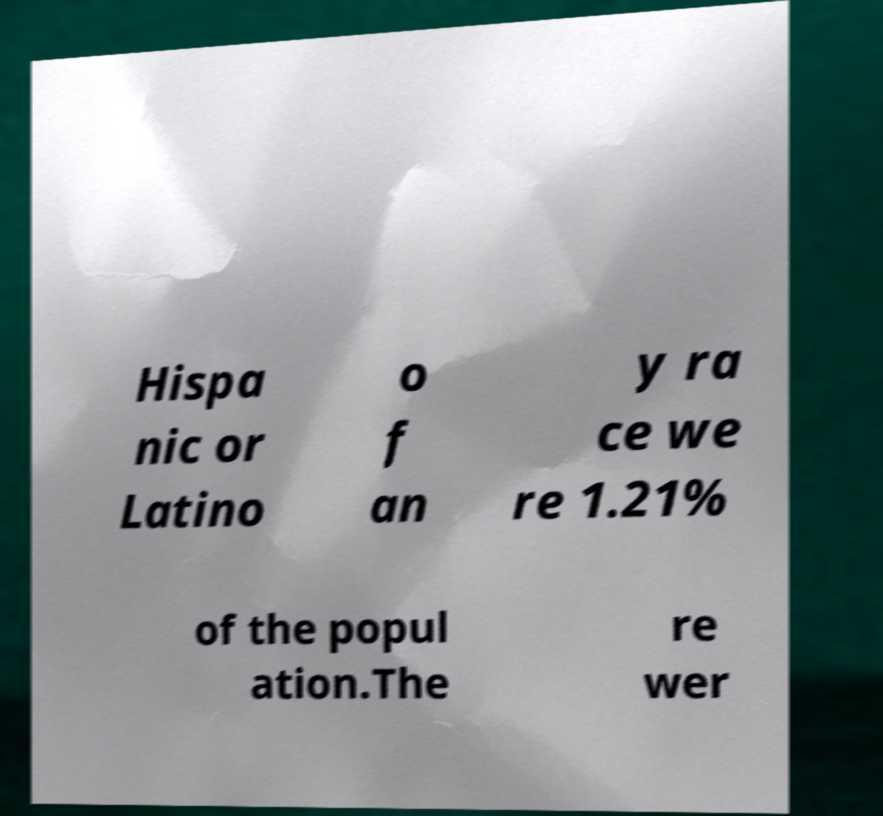For documentation purposes, I need the text within this image transcribed. Could you provide that? Hispa nic or Latino o f an y ra ce we re 1.21% of the popul ation.The re wer 